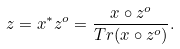<formula> <loc_0><loc_0><loc_500><loc_500>z = x ^ { * } z ^ { o } = \frac { x \circ z ^ { o } } { T r ( x \circ z ^ { o } ) } .</formula> 